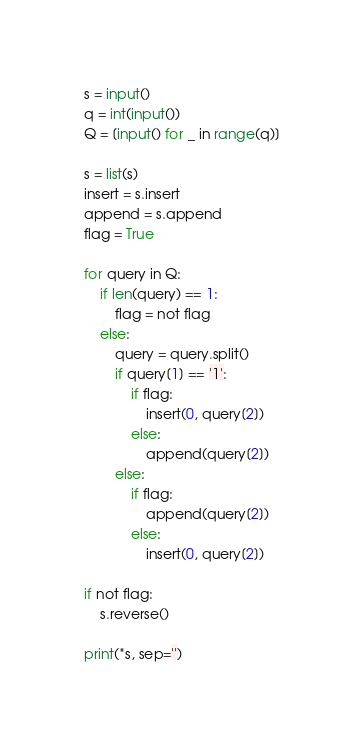<code> <loc_0><loc_0><loc_500><loc_500><_Python_>s = input()
q = int(input())
Q = [input() for _ in range(q)]

s = list(s)
insert = s.insert
append = s.append
flag = True

for query in Q:
    if len(query) == 1:
        flag = not flag
    else:
        query = query.split()
        if query[1] == '1':
            if flag:
                insert(0, query[2])
            else:
                append(query[2])
        else:
            if flag:
                append(query[2])
            else:
                insert(0, query[2])

if not flag:
    s.reverse()

print(*s, sep='')
</code> 